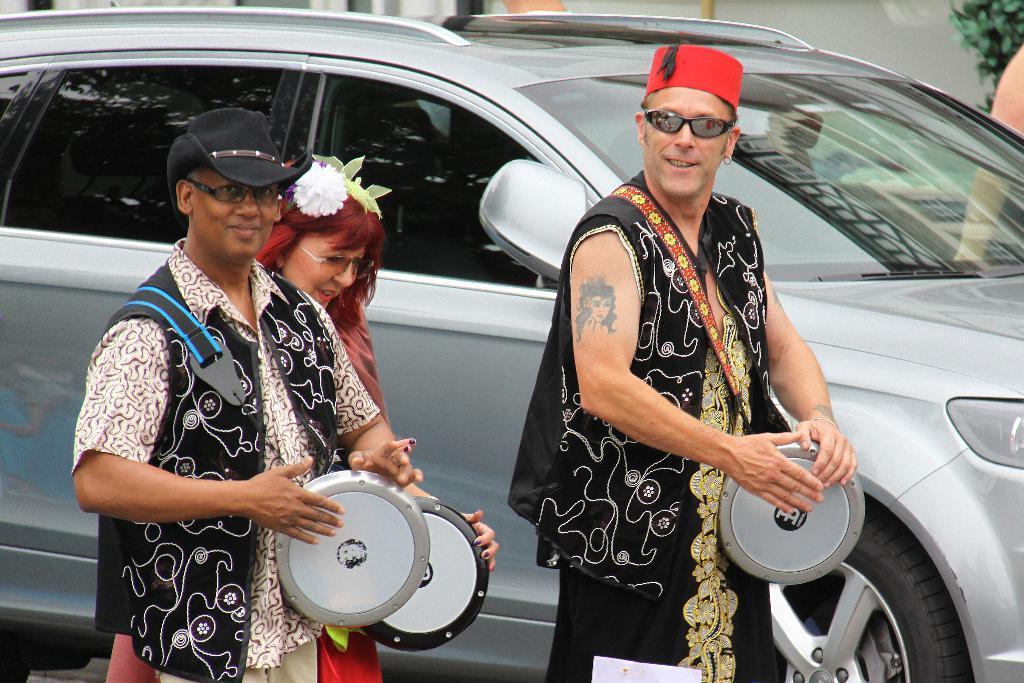In one or two sentences, can you explain what this image depicts? Two men and a woman are playing drums. There is a car behind them. 